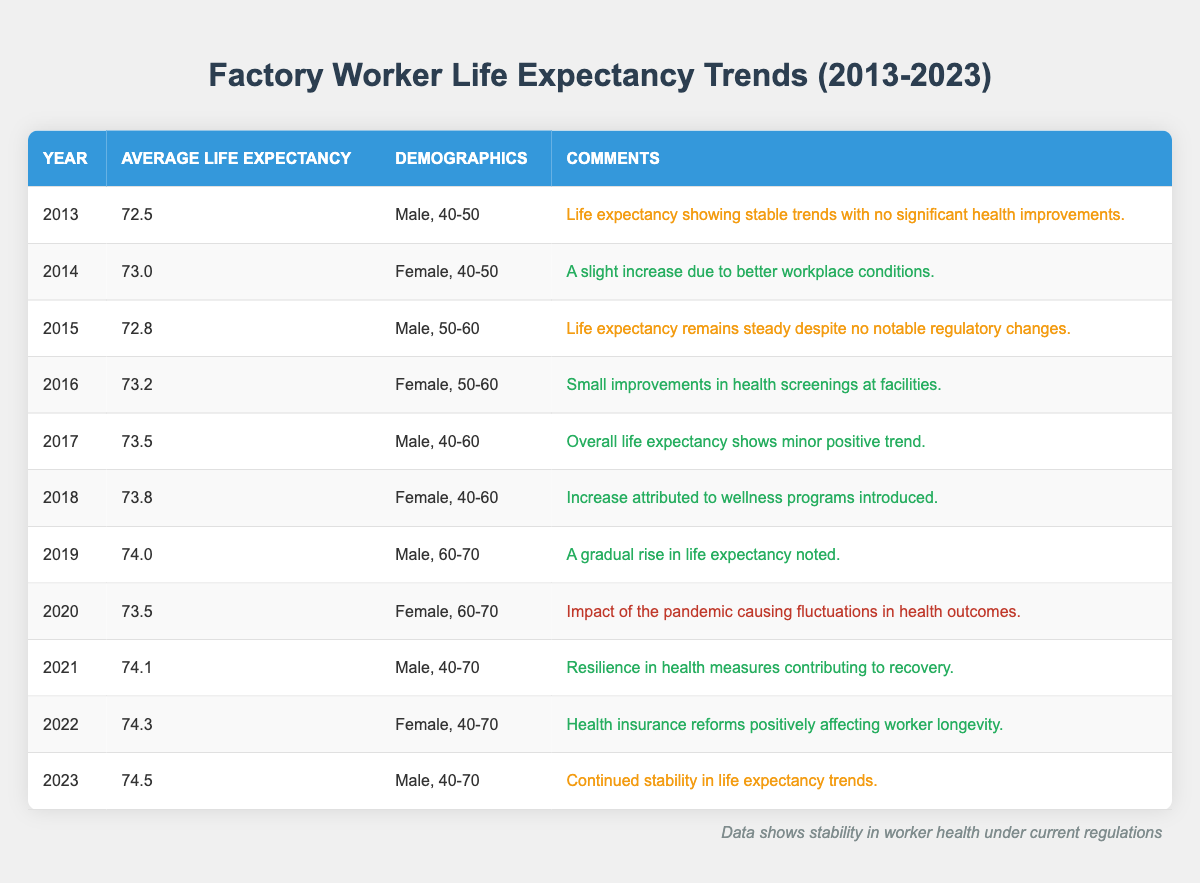What was the average life expectancy for male factory workers in 2013? Referring to the table, the average life expectancy for male factory workers in 2013 is listed as 72.5.
Answer: 72.5 Which year saw the highest average life expectancy for female factory workers in the 40-50 age group? Looking at the data, the highest average life expectancy for female factory workers aged 40-50 can be found in 2014, with a value of 73.0.
Answer: 2014 What is the difference in average life expectancy between 2013 and 2023 for male factory workers aged 40-70? The life expectancy in 2013 for males was 72.5, and in 2023 it was 74.5. The difference is 74.5 - 72.5 = 2.0.
Answer: 2.0 Did the average life expectancy for male factory workers aged 60-70 increase from 2019 to 2021? Referring to the years, in 2019 the life expectancy was 74.0 and in 2021 it was 74.1. Since 74.1 is greater than 74.0, the average did indeed increase.
Answer: Yes How many years had a life expectancy above 74 for male factory workers from 2019 to 2023? From 2019 to 2023, assessing the data, the years 2019 (74.0), 2021 (74.1), 2022 (74.3), and 2023 (74.5) showed life expectancies above 74. That totals 4 years.
Answer: 4 Was there a decline in average life expectancy for female factory workers in 2020 compared to 2019? In 2019, the average life expectancy for female factory workers was not listed in the dataset provided. Therefore, it cannot be determined if there was a decline solely from this data.
Answer: Insufficient data What trends can we observe in life expectancy for male factory workers over the last decade? Analyzing the data reveals a consistent trend of gradual increase in life expectancy, except for a slight drop in 2020 due to the pandemic, followed by a recovery.
Answer: Gradual increase with a temporary drop in 2020 What was the average life expectancy for female factory workers in 2018, and how does it compare to the previous year? The average life expectancy for female factory workers in 2018 was 73.8, which is an increase from 73.2 in 2016. This represents a 0.6 increase over two years.
Answer: 73.8 Did the introduction of wellness programs have a positive impact on life expectancy trends? The data indicates that life expectancy increased following the introduction of wellness programs in 2018, as it went from 73.5 in 2017 to 73.8 in 2018.
Answer: Yes 